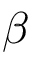Convert formula to latex. <formula><loc_0><loc_0><loc_500><loc_500>\beta</formula> 